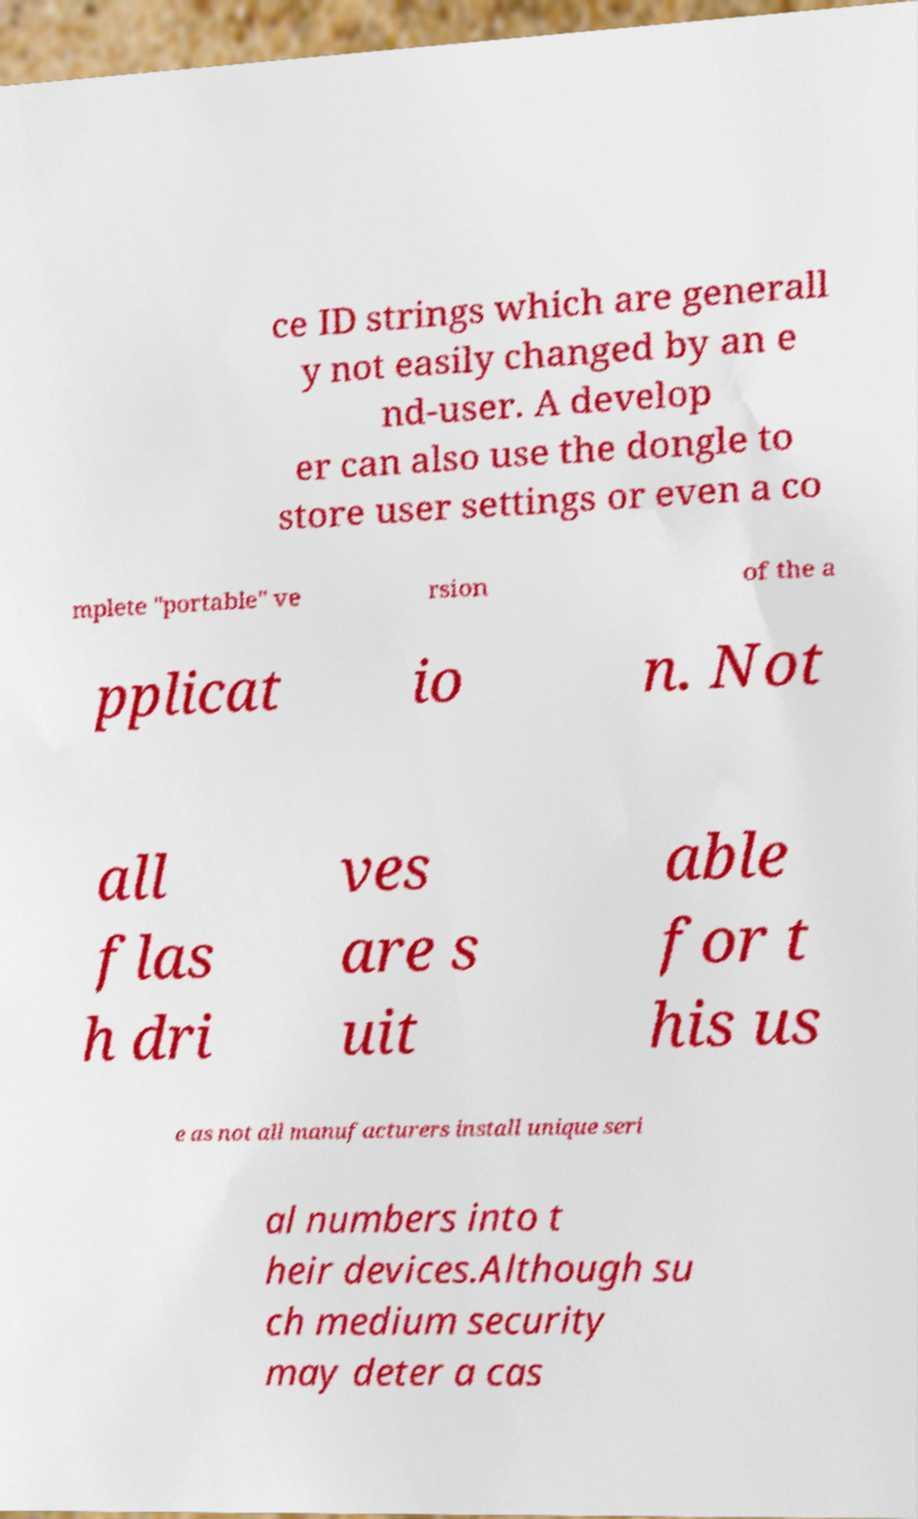Can you accurately transcribe the text from the provided image for me? ce ID strings which are generall y not easily changed by an e nd-user. A develop er can also use the dongle to store user settings or even a co mplete "portable" ve rsion of the a pplicat io n. Not all flas h dri ves are s uit able for t his us e as not all manufacturers install unique seri al numbers into t heir devices.Although su ch medium security may deter a cas 